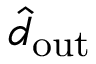Convert formula to latex. <formula><loc_0><loc_0><loc_500><loc_500>\hat { d } _ { o u t }</formula> 